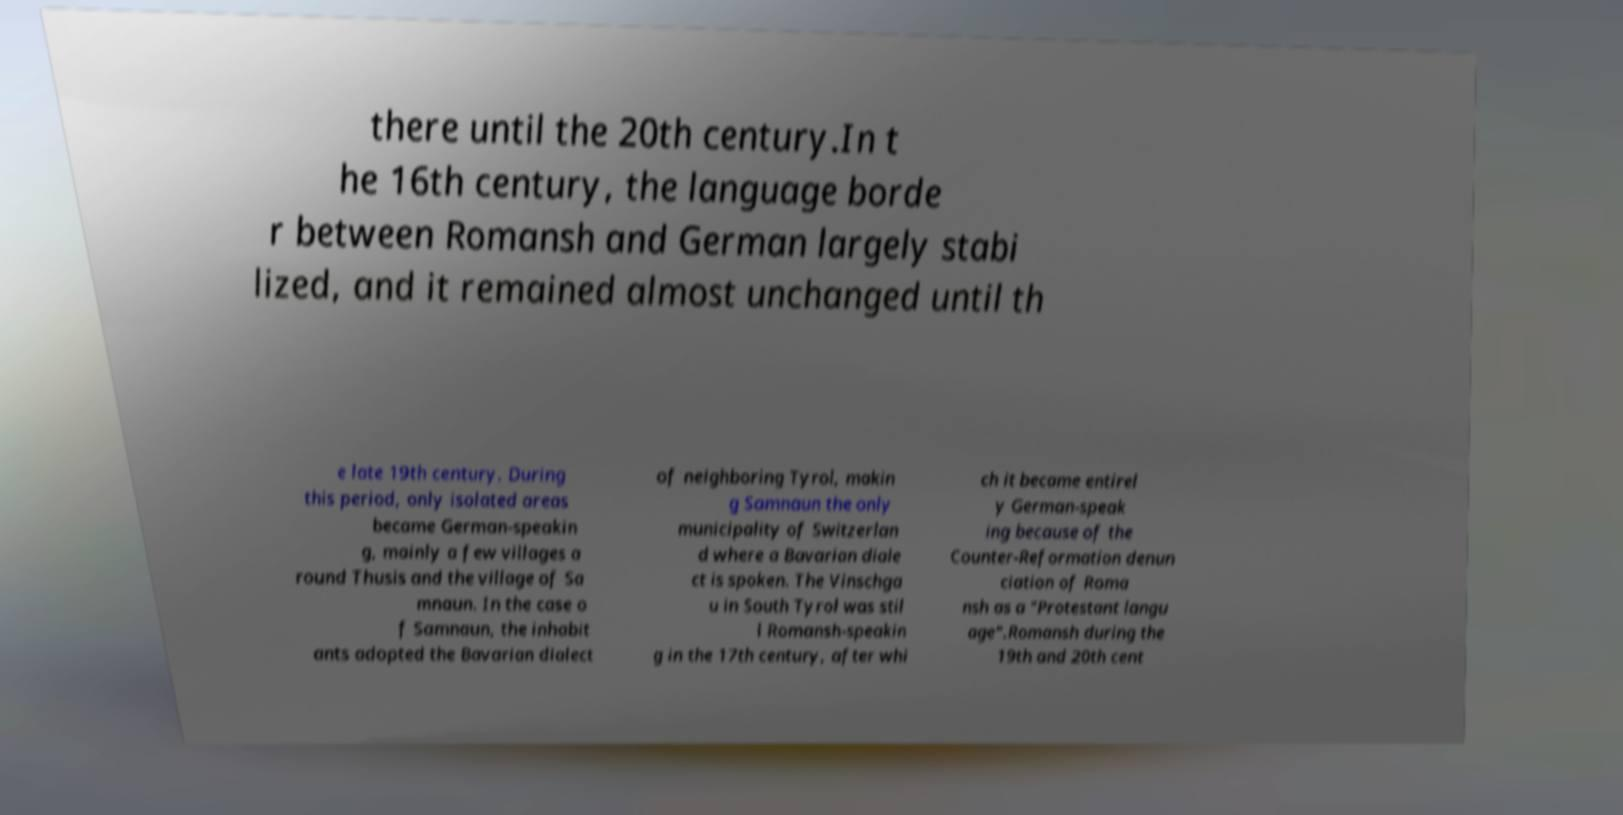Could you assist in decoding the text presented in this image and type it out clearly? there until the 20th century.In t he 16th century, the language borde r between Romansh and German largely stabi lized, and it remained almost unchanged until th e late 19th century. During this period, only isolated areas became German-speakin g, mainly a few villages a round Thusis and the village of Sa mnaun. In the case o f Samnaun, the inhabit ants adopted the Bavarian dialect of neighboring Tyrol, makin g Samnaun the only municipality of Switzerlan d where a Bavarian diale ct is spoken. The Vinschga u in South Tyrol was stil l Romansh-speakin g in the 17th century, after whi ch it became entirel y German-speak ing because of the Counter-Reformation denun ciation of Roma nsh as a "Protestant langu age".Romansh during the 19th and 20th cent 